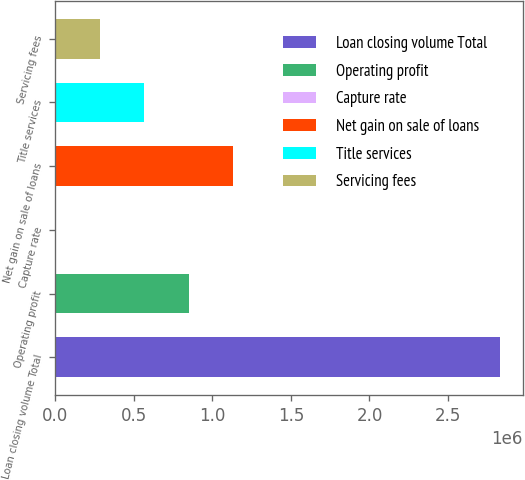Convert chart to OTSL. <chart><loc_0><loc_0><loc_500><loc_500><bar_chart><fcel>Loan closing volume Total<fcel>Operating profit<fcel>Capture rate<fcel>Net gain on sale of loans<fcel>Title services<fcel>Servicing fees<nl><fcel>2.83361e+06<fcel>850142<fcel>84<fcel>1.1335e+06<fcel>566790<fcel>283437<nl></chart> 